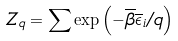Convert formula to latex. <formula><loc_0><loc_0><loc_500><loc_500>Z _ { q } = \sum \exp \left ( - \overline { \beta } \overline { \epsilon } _ { i } / q \right )</formula> 